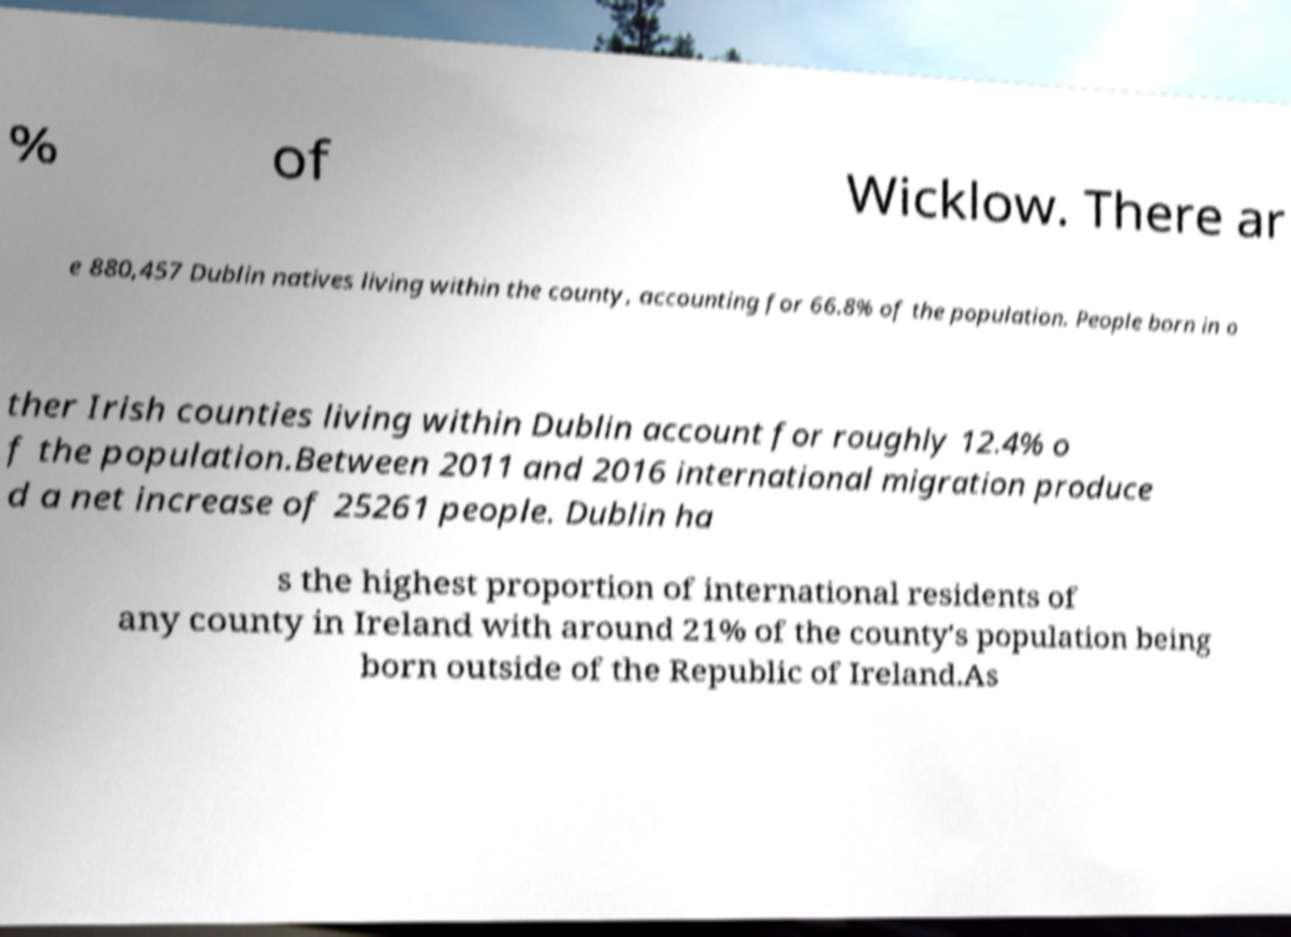Please read and relay the text visible in this image. What does it say? % of Wicklow. There ar e 880,457 Dublin natives living within the county, accounting for 66.8% of the population. People born in o ther Irish counties living within Dublin account for roughly 12.4% o f the population.Between 2011 and 2016 international migration produce d a net increase of 25261 people. Dublin ha s the highest proportion of international residents of any county in Ireland with around 21% of the county's population being born outside of the Republic of Ireland.As 